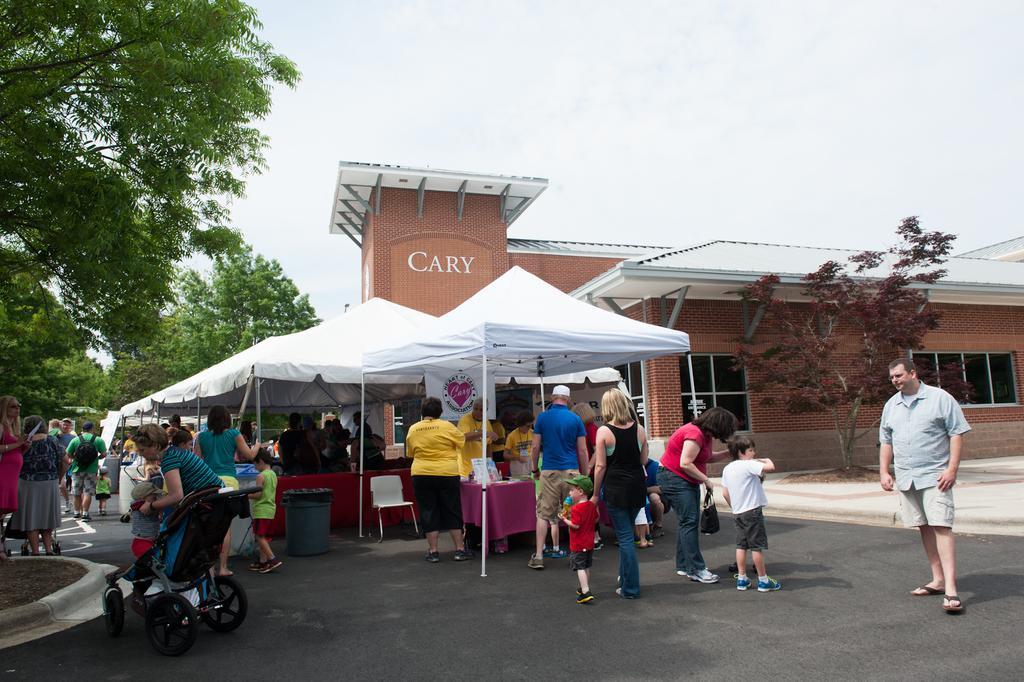How would you summarize this image in a sentence or two? This picture might be taken from outside of the building and it is sunny. In this image, on the right side, we can see a man standing on the road. On the left side, we can see a woman holding a kid in her hand. In the middle of the image, we can see a few people are walking on the road and few people are standing in front of the stalls, we can also see dustbin, chair, table, tents in the middle. On the left side, we can also see a group of trees, people. In the background, we can see a building, trees. At the top, we can see a sky, at the bottom there is a road and a land. 